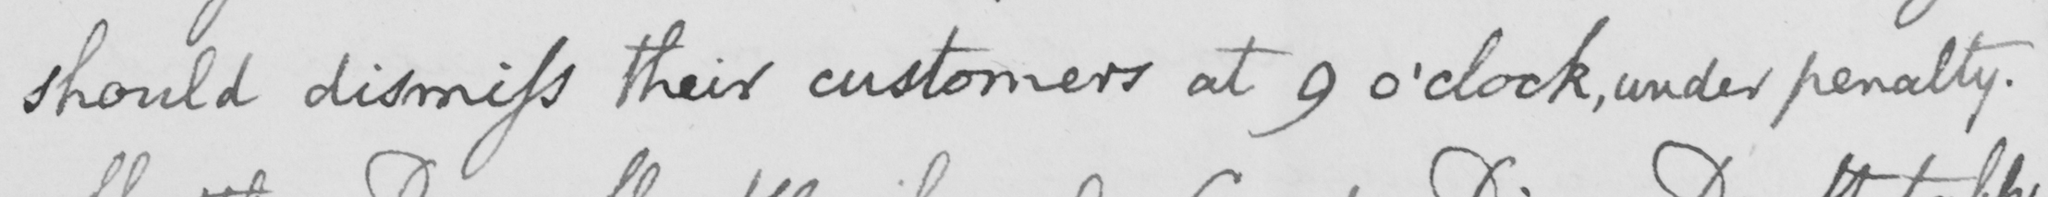Can you read and transcribe this handwriting? should dismiss their customers at 9 o ' clock , under penalty . 